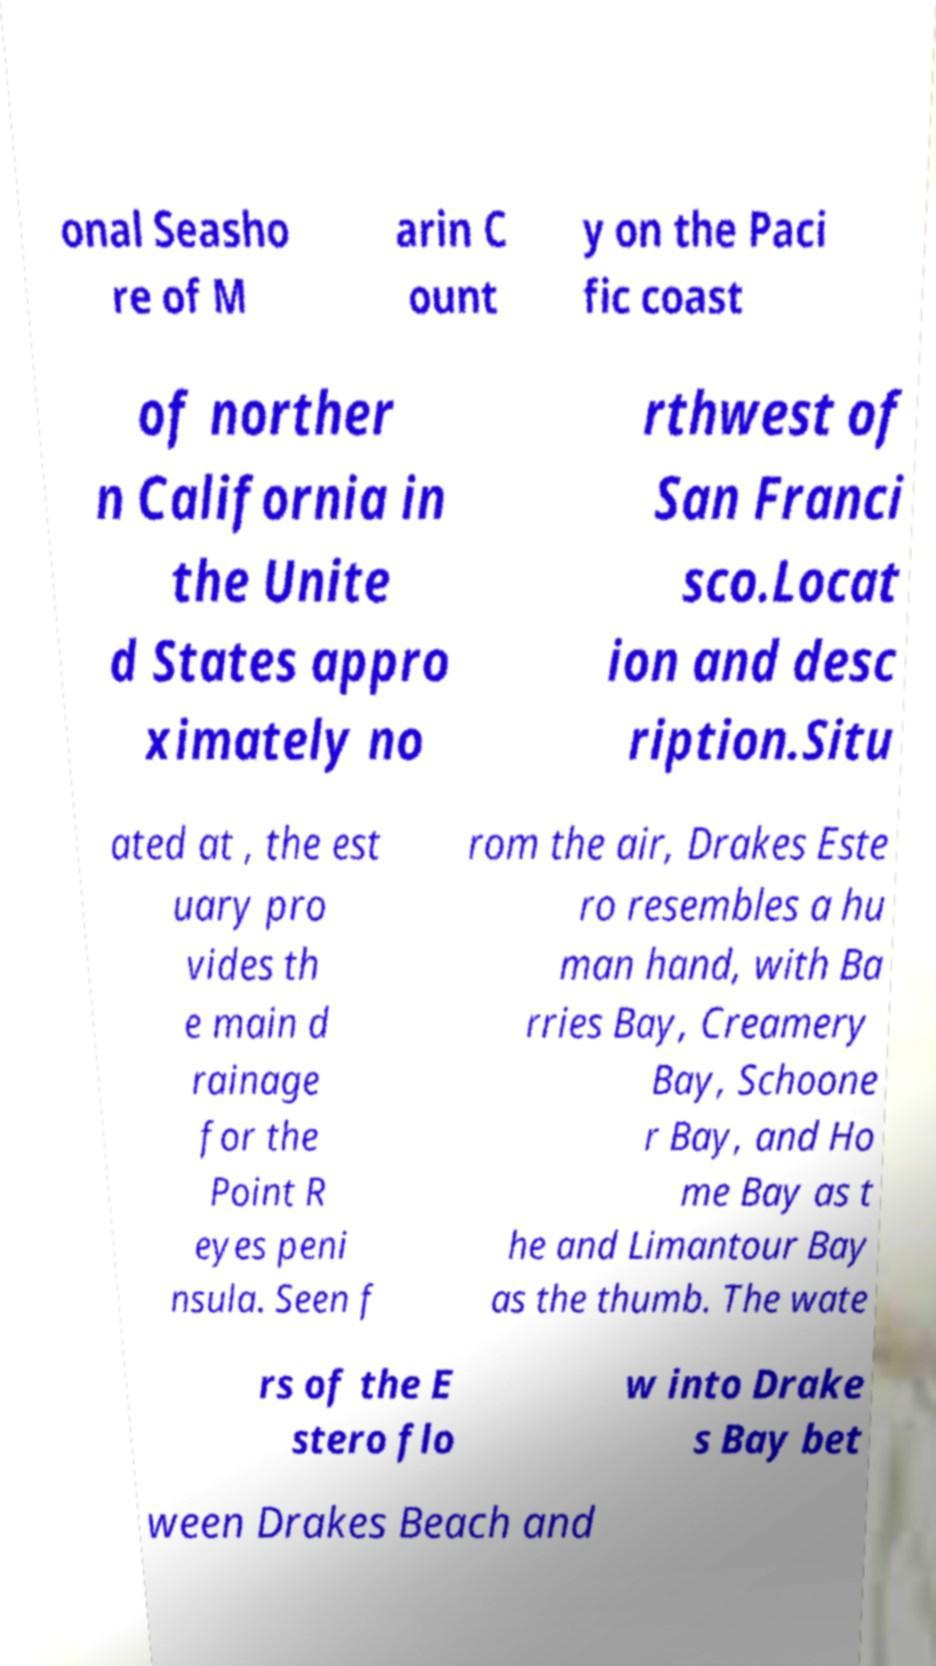Please read and relay the text visible in this image. What does it say? onal Seasho re of M arin C ount y on the Paci fic coast of norther n California in the Unite d States appro ximately no rthwest of San Franci sco.Locat ion and desc ription.Situ ated at , the est uary pro vides th e main d rainage for the Point R eyes peni nsula. Seen f rom the air, Drakes Este ro resembles a hu man hand, with Ba rries Bay, Creamery Bay, Schoone r Bay, and Ho me Bay as t he and Limantour Bay as the thumb. The wate rs of the E stero flo w into Drake s Bay bet ween Drakes Beach and 